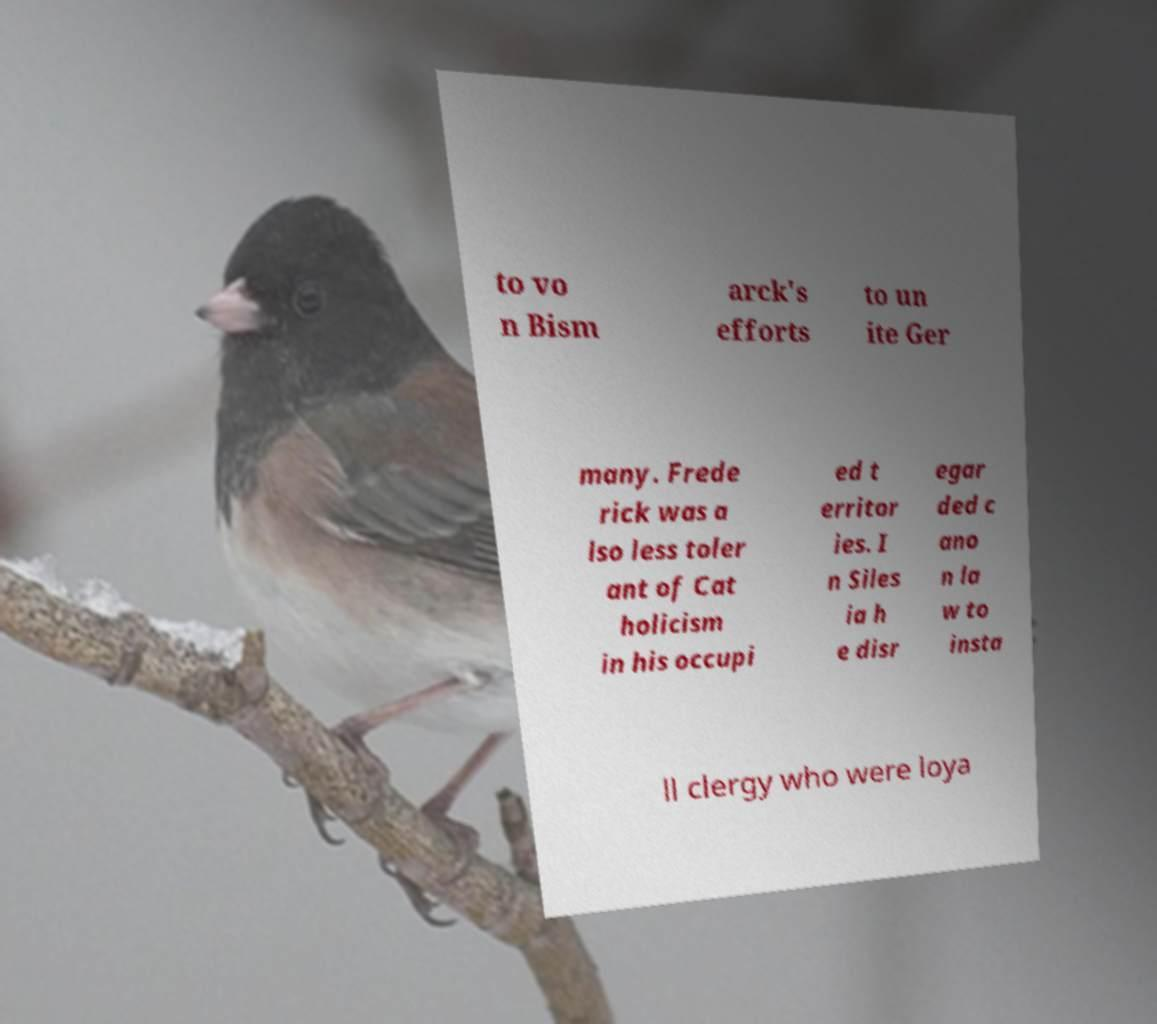Could you assist in decoding the text presented in this image and type it out clearly? to vo n Bism arck's efforts to un ite Ger many. Frede rick was a lso less toler ant of Cat holicism in his occupi ed t erritor ies. I n Siles ia h e disr egar ded c ano n la w to insta ll clergy who were loya 